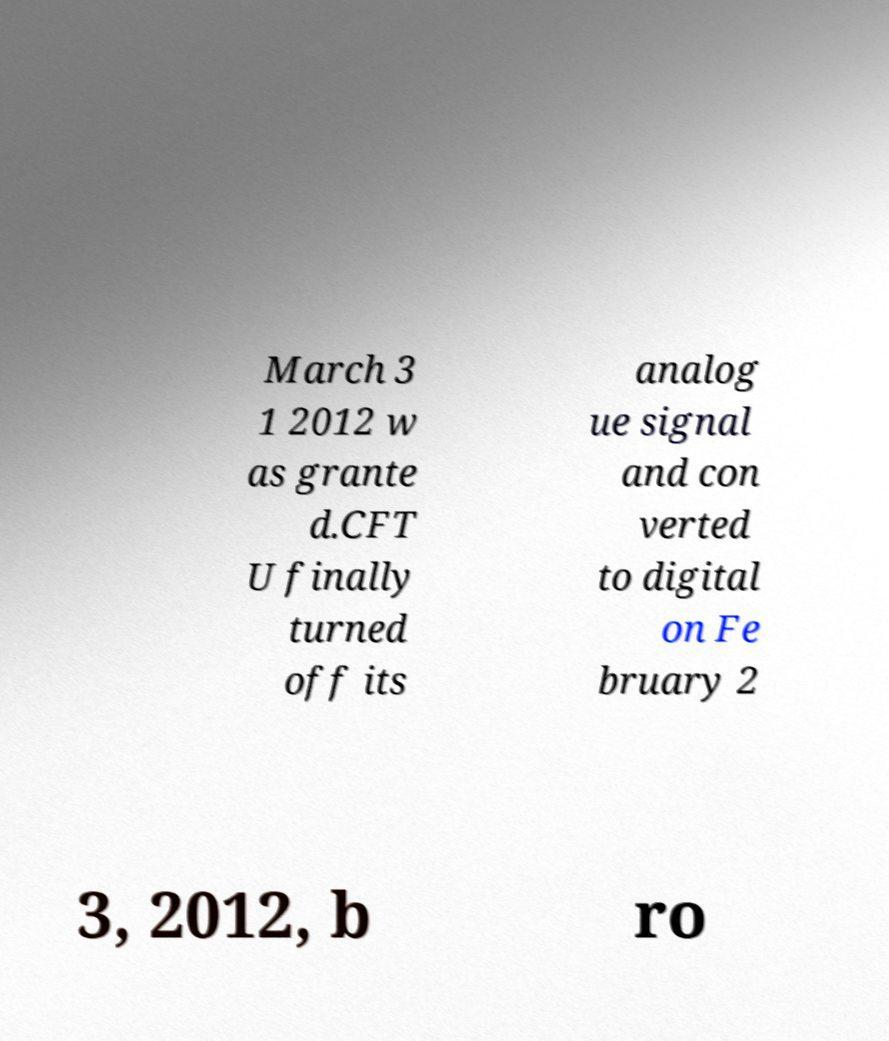Can you read and provide the text displayed in the image?This photo seems to have some interesting text. Can you extract and type it out for me? March 3 1 2012 w as grante d.CFT U finally turned off its analog ue signal and con verted to digital on Fe bruary 2 3, 2012, b ro 